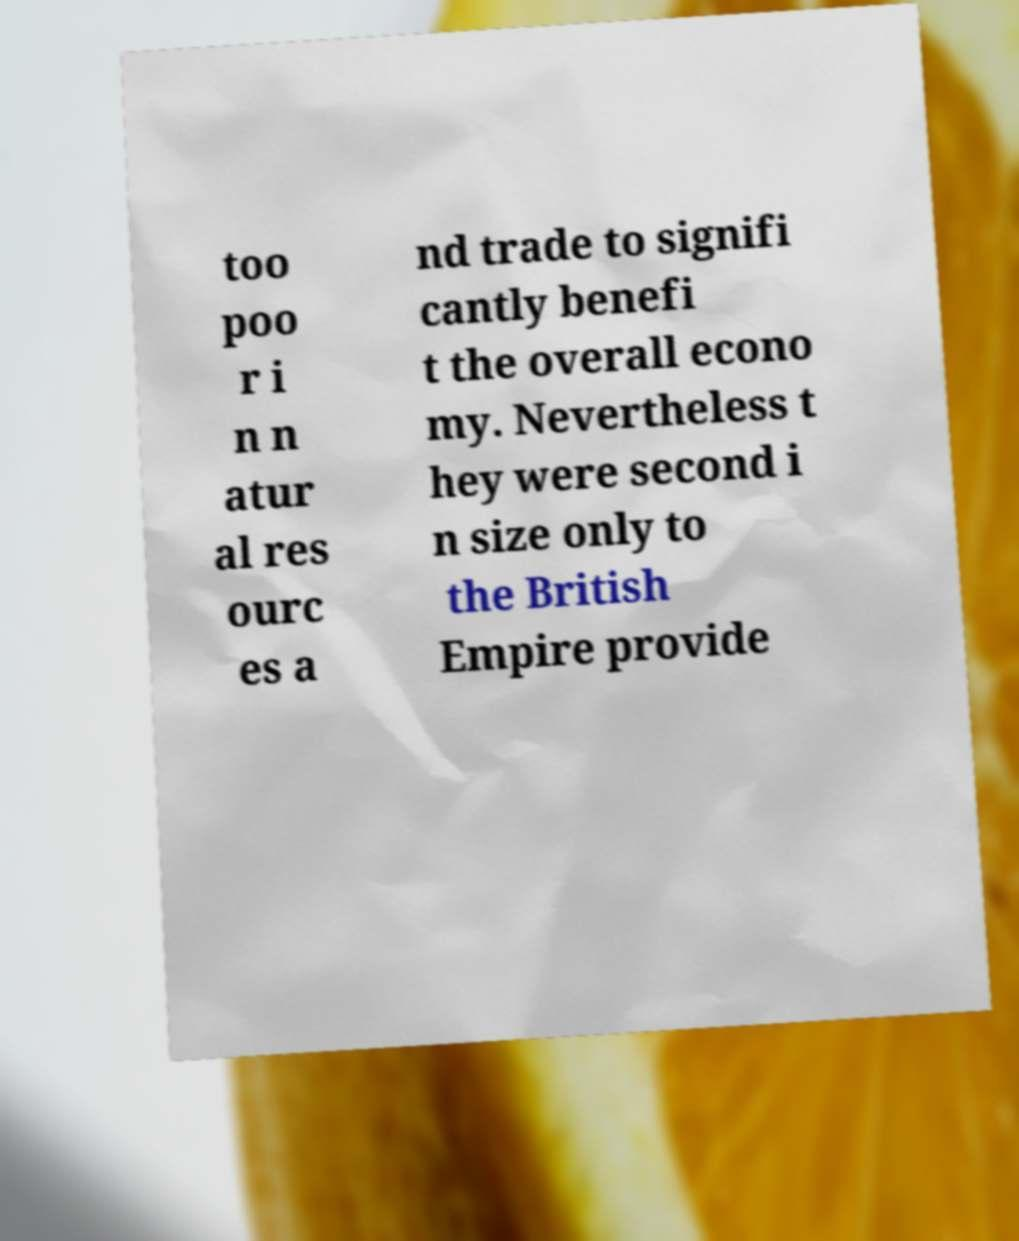Please identify and transcribe the text found in this image. too poo r i n n atur al res ourc es a nd trade to signifi cantly benefi t the overall econo my. Nevertheless t hey were second i n size only to the British Empire provide 